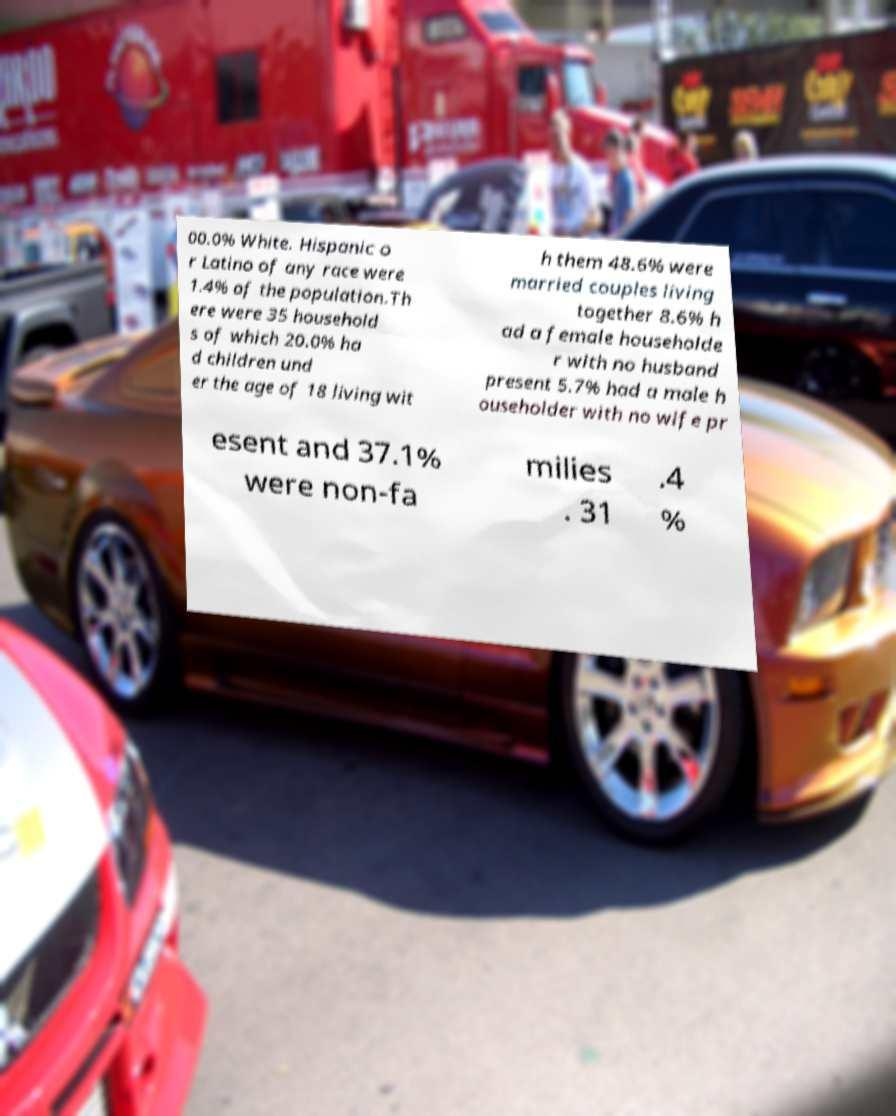Could you assist in decoding the text presented in this image and type it out clearly? 00.0% White. Hispanic o r Latino of any race were 1.4% of the population.Th ere were 35 household s of which 20.0% ha d children und er the age of 18 living wit h them 48.6% were married couples living together 8.6% h ad a female householde r with no husband present 5.7% had a male h ouseholder with no wife pr esent and 37.1% were non-fa milies . 31 .4 % 